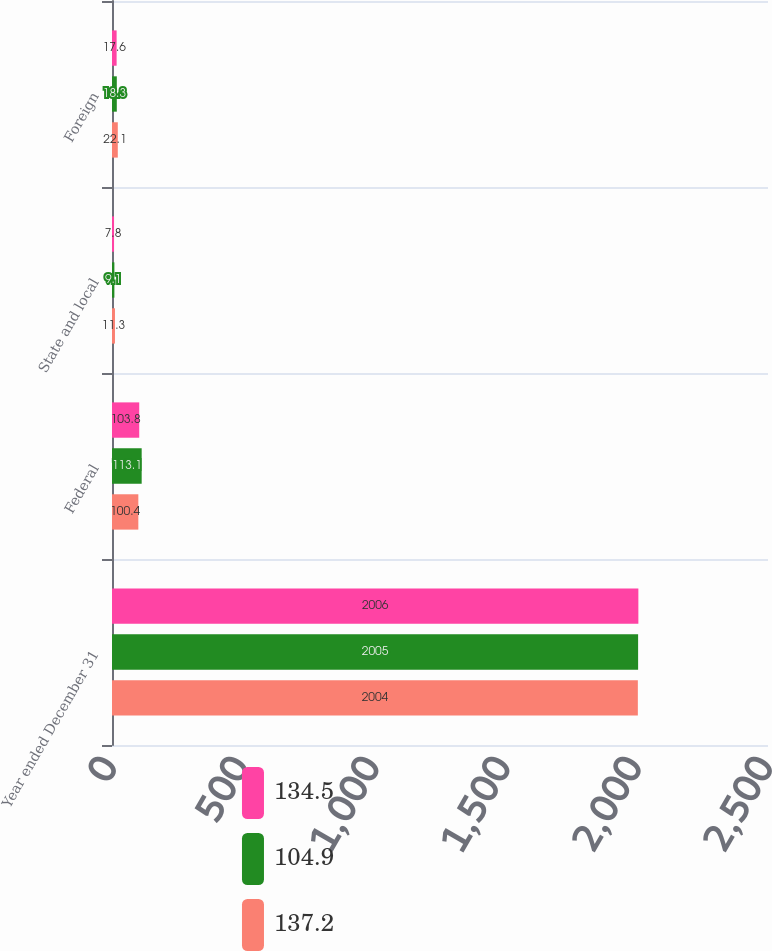<chart> <loc_0><loc_0><loc_500><loc_500><stacked_bar_chart><ecel><fcel>Year ended December 31<fcel>Federal<fcel>State and local<fcel>Foreign<nl><fcel>134.5<fcel>2006<fcel>103.8<fcel>7.8<fcel>17.6<nl><fcel>104.9<fcel>2005<fcel>113.1<fcel>9.1<fcel>18.3<nl><fcel>137.2<fcel>2004<fcel>100.4<fcel>11.3<fcel>22.1<nl></chart> 